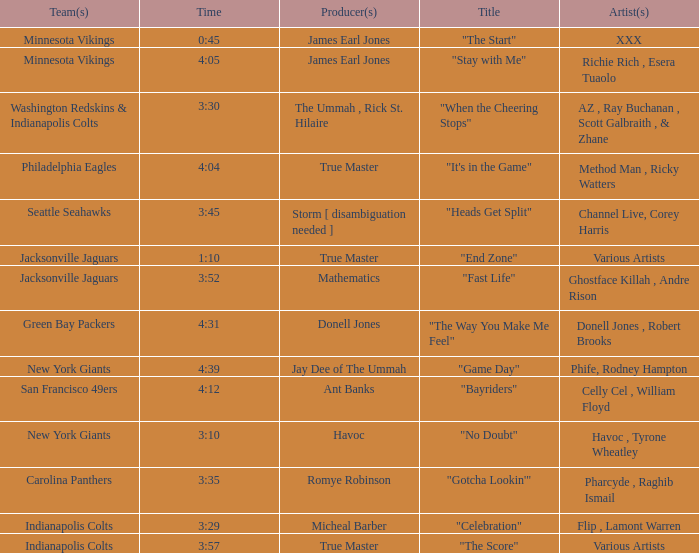How long is the XXX track used by the Minnesota Vikings? 0:45. Can you parse all the data within this table? {'header': ['Team(s)', 'Time', 'Producer(s)', 'Title', 'Artist(s)'], 'rows': [['Minnesota Vikings', '0:45', 'James Earl Jones', '"The Start"', 'XXX'], ['Minnesota Vikings', '4:05', 'James Earl Jones', '"Stay with Me"', 'Richie Rich , Esera Tuaolo'], ['Washington Redskins & Indianapolis Colts', '3:30', 'The Ummah , Rick St. Hilaire', '"When the Cheering Stops"', 'AZ , Ray Buchanan , Scott Galbraith , & Zhane'], ['Philadelphia Eagles', '4:04', 'True Master', '"It\'s in the Game"', 'Method Man , Ricky Watters'], ['Seattle Seahawks', '3:45', 'Storm [ disambiguation needed ]', '"Heads Get Split"', 'Channel Live, Corey Harris'], ['Jacksonville Jaguars', '1:10', 'True Master', '"End Zone"', 'Various Artists'], ['Jacksonville Jaguars', '3:52', 'Mathematics', '"Fast Life"', 'Ghostface Killah , Andre Rison'], ['Green Bay Packers', '4:31', 'Donell Jones', '"The Way You Make Me Feel"', 'Donell Jones , Robert Brooks'], ['New York Giants', '4:39', 'Jay Dee of The Ummah', '"Game Day"', 'Phife, Rodney Hampton'], ['San Francisco 49ers', '4:12', 'Ant Banks', '"Bayriders"', 'Celly Cel , William Floyd'], ['New York Giants', '3:10', 'Havoc', '"No Doubt"', 'Havoc , Tyrone Wheatley'], ['Carolina Panthers', '3:35', 'Romye Robinson', '"Gotcha Lookin\'"', 'Pharcyde , Raghib Ismail'], ['Indianapolis Colts', '3:29', 'Micheal Barber', '"Celebration"', 'Flip , Lamont Warren'], ['Indianapolis Colts', '3:57', 'True Master', '"The Score"', 'Various Artists']]} 